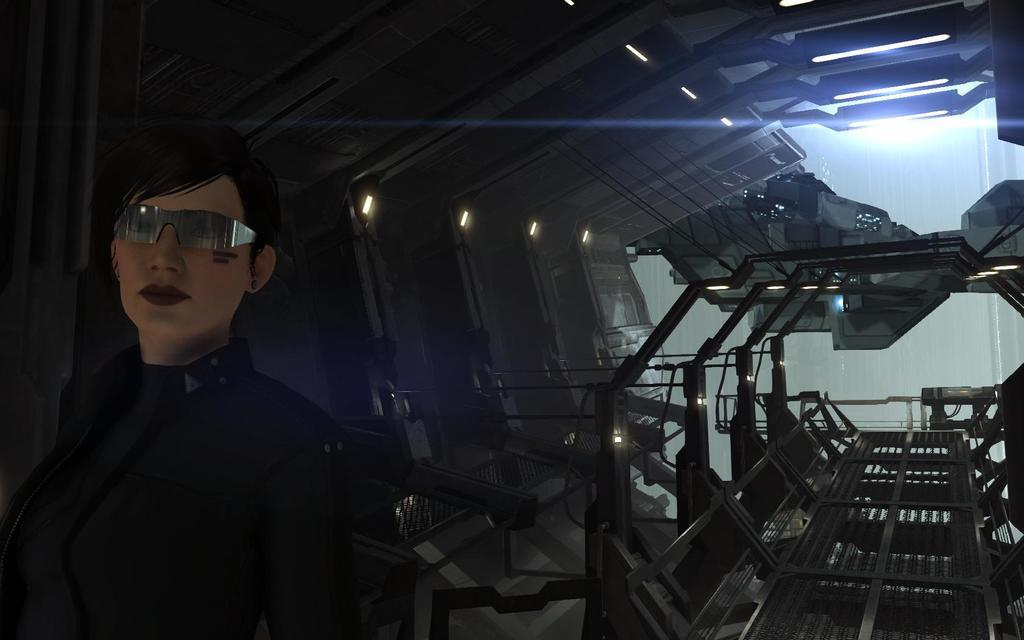What is a characteristic of the person in the animation? The person in the animation is wearing glasses. What can be seen in the background of the animation? There is a machine in the background of the animation. What can be observed in the animation that provides illumination? There are lights visible in the animation. What type of structure is present in the animation? There is a wall in the animation. What type of pan is being used by the person in the animation? There is no pan present in the animation; the person is wearing glasses. What type of joke is being told by the person in the animation? There is no joke being told in the animation; the person is wearing glasses. 